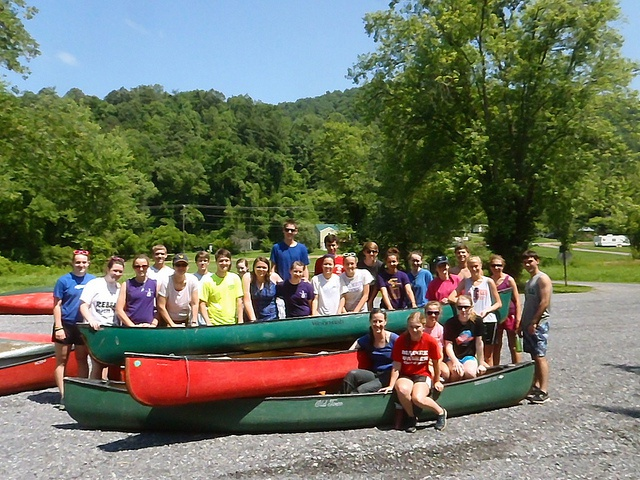Describe the objects in this image and their specific colors. I can see boat in gray, black, teal, and red tones, people in gray, black, maroon, and white tones, boat in gray, lightgray, lightpink, maroon, and brown tones, people in gray, black, maroon, lightgray, and navy tones, and people in gray, black, maroon, and darkgray tones in this image. 